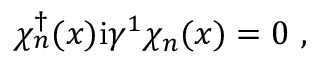Convert formula to latex. <formula><loc_0><loc_0><loc_500><loc_500>\chi _ { n } ^ { \dagger } ( x ) i \gamma ^ { 1 } \chi _ { n } ( x ) = 0 \ ,</formula> 